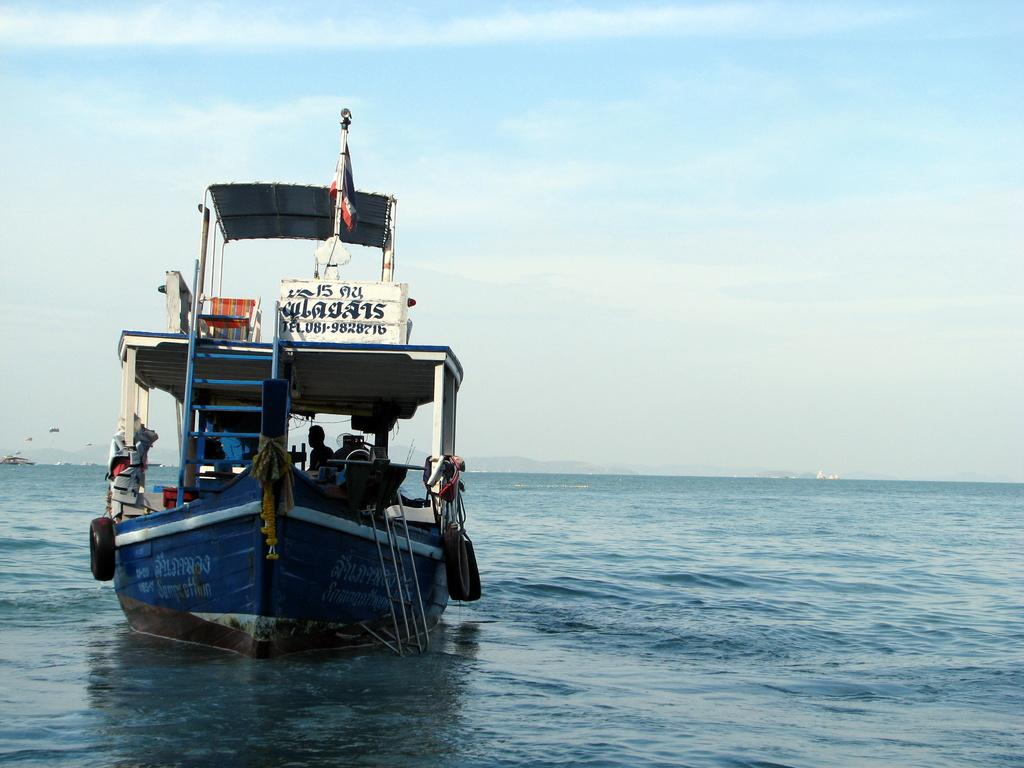What is the main subject of the image? The main subject of the image is a boat sailing on the water. Are there any other boats visible in the image? Yes, there are other boats in the backdrop of the image. What is the condition of the sky in the image? The sky is clear in the image. How many sisters are sitting in the office in the image? There is no office or sisters present in the image; it features a boat sailing on the water with other boats in the backdrop and a clear sky. 